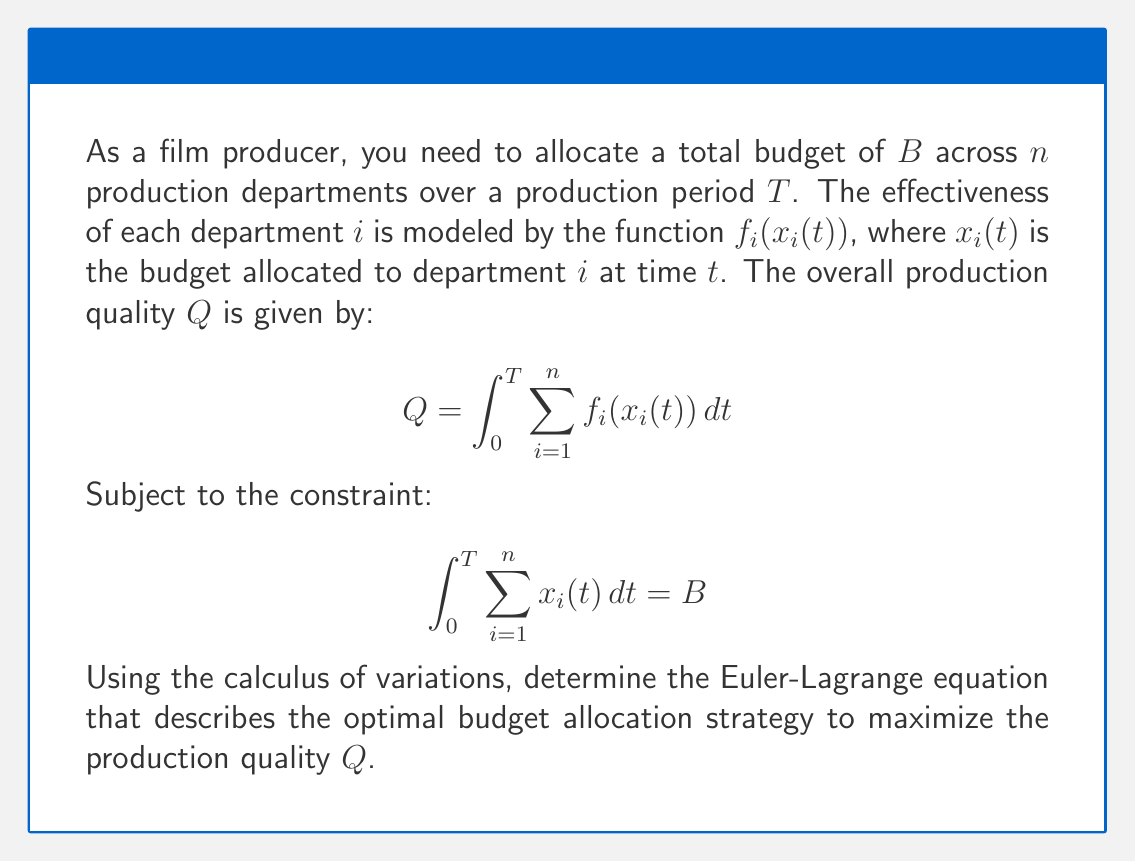Solve this math problem. To solve this problem using calculus of variations, we follow these steps:

1) First, we form the augmented functional $J$ by introducing a Lagrange multiplier $\lambda$:

   $$J = \int_0^T \left[\sum_{i=1}^n f_i(x_i(t)) + \lambda\left(B - \sum_{i=1}^n x_i(t)\right)\right] dt$$

2) The Euler-Lagrange equation for each $x_i(t)$ is:

   $$\frac{\partial}{\partial x_i}\left(\sum_{i=1}^n f_i(x_i(t)) + \lambda\left(B - \sum_{i=1}^n x_i(t)\right)\right) = 0$$

3) Simplifying this equation:

   $$\frac{\partial f_i(x_i(t))}{\partial x_i} - \lambda = 0$$

4) This can be rewritten as:

   $$f'_i(x_i(t)) = \lambda$$

5) This equation must hold for all $i$ from 1 to $n$. Therefore, we can say:

   $$f'_1(x_1(t)) = f'_2(x_2(t)) = ... = f'_n(x_n(t)) = \lambda$$

This is the Euler-Lagrange equation that describes the optimal budget allocation strategy.
Answer: $f'_1(x_1(t)) = f'_2(x_2(t)) = ... = f'_n(x_n(t)) = \lambda$ 